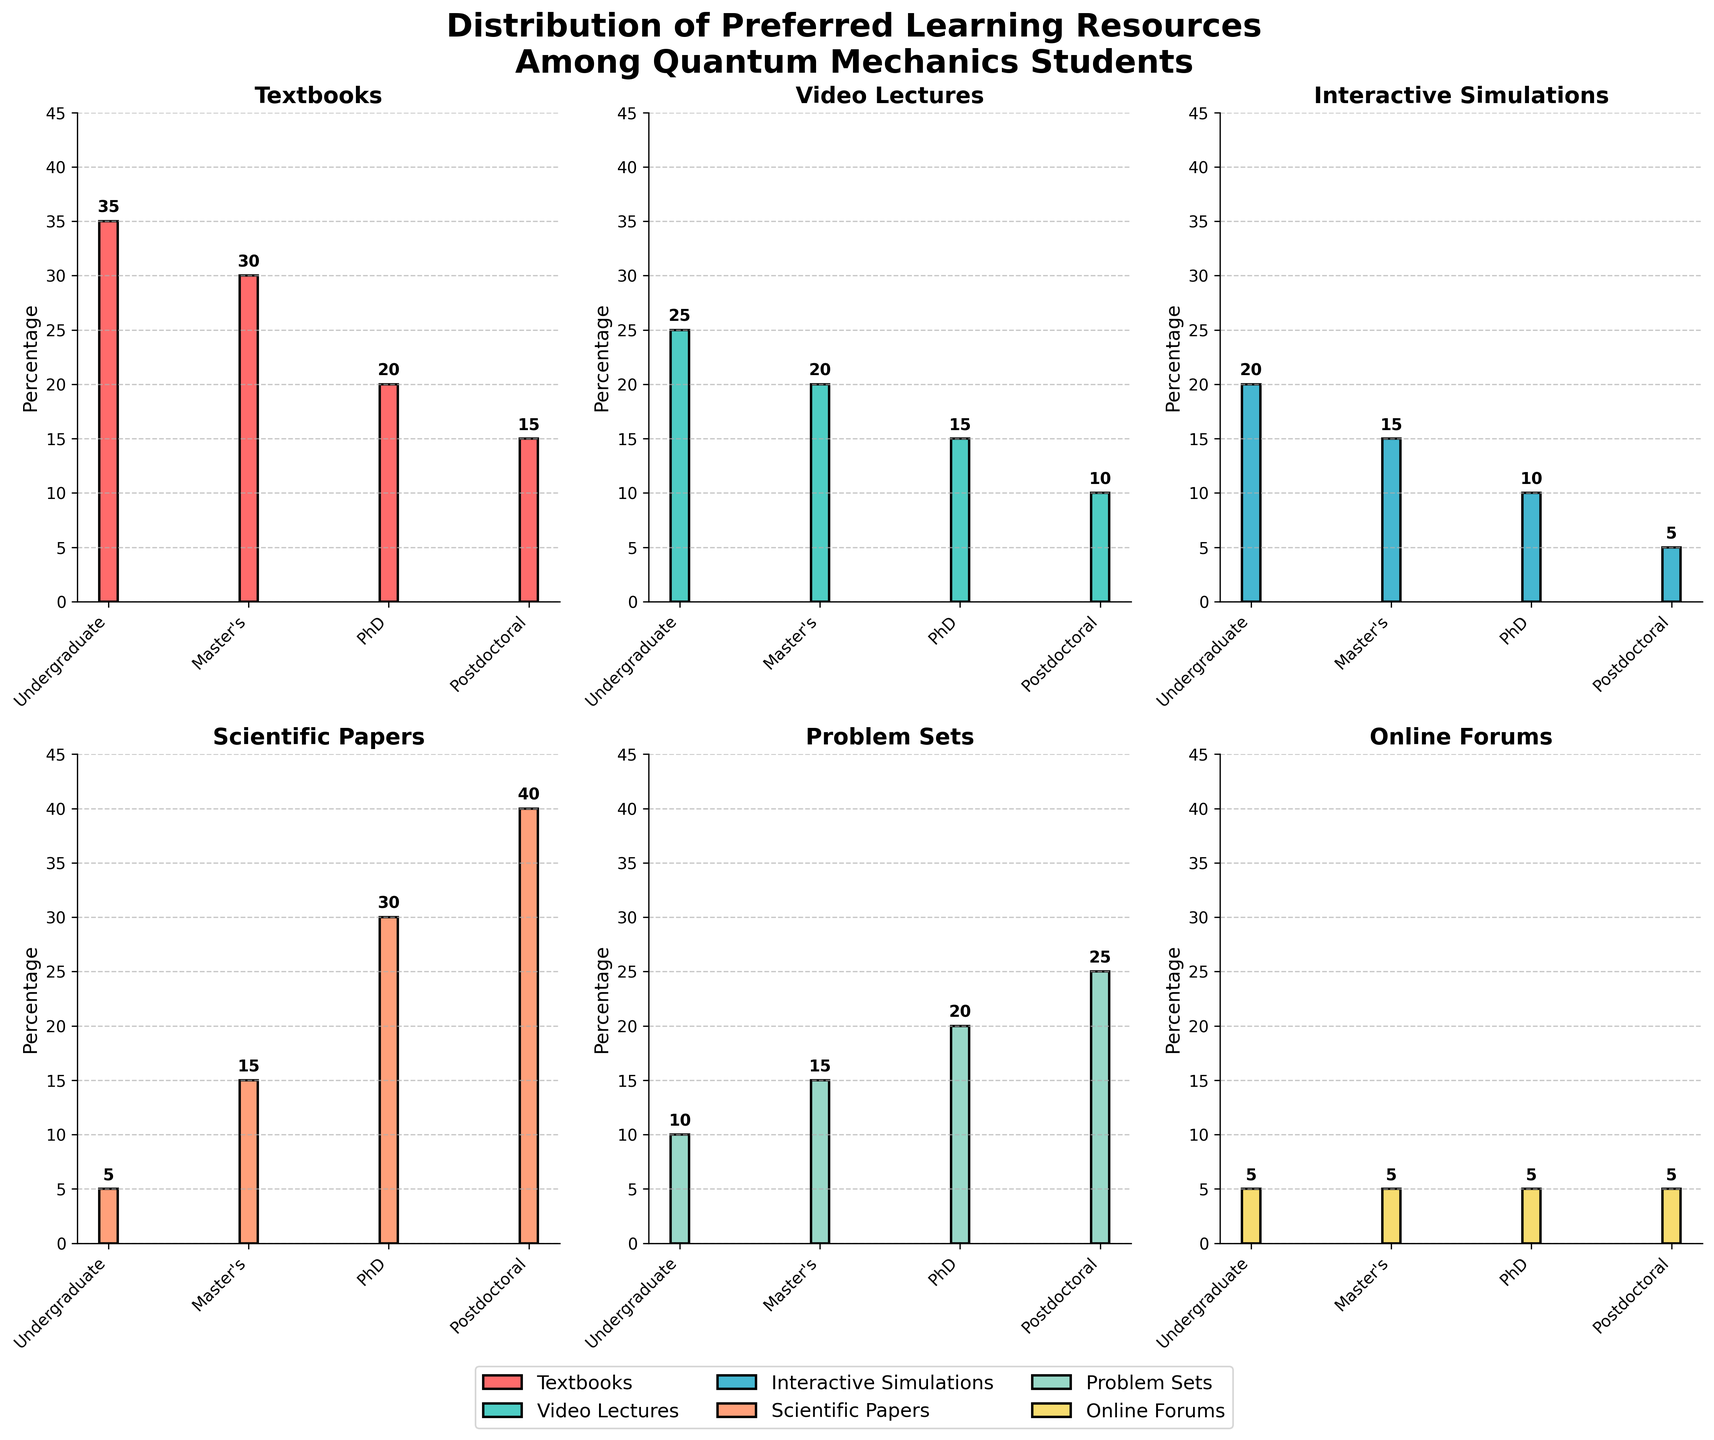Which academic level has the highest preference for scientific papers? To find the answer, look at the bar chart for "Scientific Papers" and compare the heights of the bars. The highest bar corresponds to the Postdoctoral level.
Answer: Postdoctoral Which learning resource has the lowest preference among undergraduate students? For the Undergraduate level, compare the heights of all bars. The lowest bar is for "Scientific Papers" and "Online Forums," both at 5%.
Answer: Scientific Papers and Online Forums What is the sum of preferences for interactive simulations across all academic levels? Add up the values for "Interactive Simulations" at each academic level: 20 (Undergraduate) + 15 (Master's) + 10 (PhD) + 5 (Postdoctoral) = 50.
Answer: 50 How does the preference for problem sets change from undergraduate to postdoctoral levels? Observe the "Problem Sets" bars across all levels. Undergraduates start at 10%, Master's increase to 15%, PhD's increase to 20%, and Postdoctoral levels are the highest at 25%.
Answer: Increases Which academic level has the most evenly distributed preference across all learning resources? Look for the academic level where the bars are most similar in height. The Master's level shows the most even distribution, with values fairly close for all resources.
Answer: Master's What is the difference in preference for textbooks between undergraduate and postdoctoral levels? Subtract the value at the Postdoctoral level from the value at the Undergraduate level for "Textbooks": 35% (Undergraduate) - 15% (Postdoctoral) = 20%.
Answer: 20% Rank the learning resources preferred by PhD students from highest to lowest. For the PhD level, list the resources in order of bar height: Scientific Papers (30%), Problem Sets (20%), Textbooks (20%), Video Lectures (15%), Interactive Simulations (10%), Online Forums (5%).
Answer: Scientific Papers > Problem Sets > Textbooks > Video Lectures > Interactive Simulations > Online Forums Do video lectures become more or less preferred as the academic level increases? Examine the "Video Lectures" bars across academic levels. The preference decreases from Undergraduate (25%), to Master's (20%), to PhD (15%), and further to Postdoctoral (10%).
Answer: Less What is the total preference percentage for online forums across all academic levels? Add up the values for "Online Forums" at each academic level: 5 (Undergraduate) + 5 (Master's) + 5 (PhD) + 5 (Postdoctoral) = 20.
Answer: 20 Which two resources are equally preferred by undergraduate students? Look at the Undergraduate level and identify bars of the same height. "Scientific Papers" and "Online Forums" are both at 5%.
Answer: Scientific Papers and Online Forums 